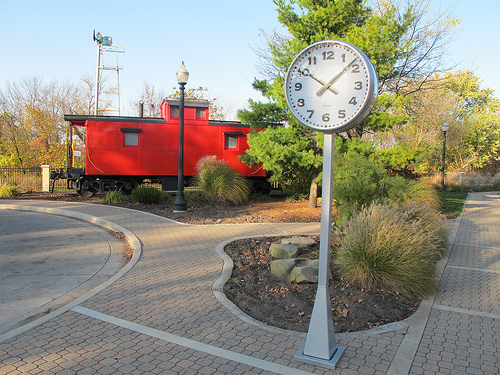<image>
Is the clock next to the train car? No. The clock is not positioned next to the train car. They are located in different areas of the scene. 